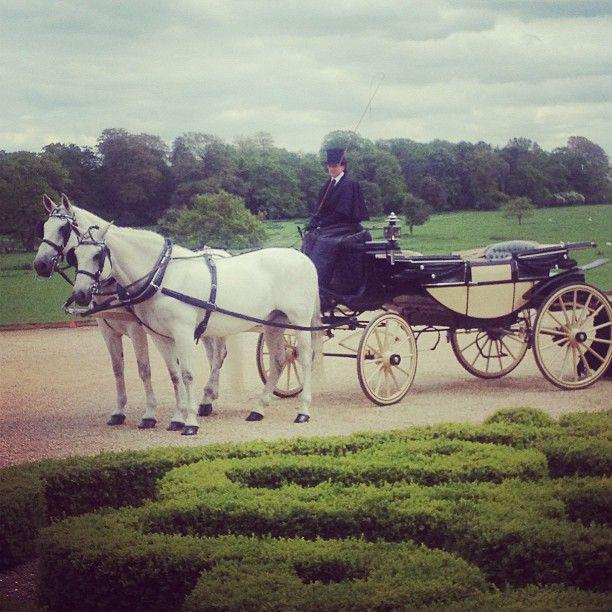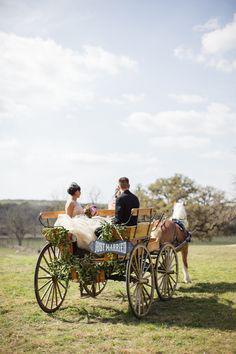The first image is the image on the left, the second image is the image on the right. Assess this claim about the two images: "There are three or more horses in at least one image.". Correct or not? Answer yes or no. No. The first image is the image on the left, the second image is the image on the right. For the images shown, is this caption "Has atleast one image with more than 3 horses" true? Answer yes or no. No. 